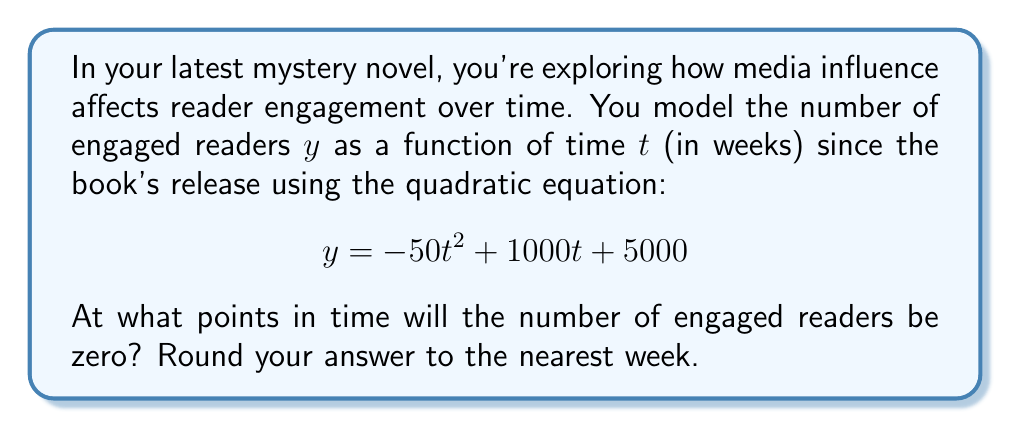Can you answer this question? To find when the number of engaged readers will be zero, we need to solve the equation:

$$ -50t^2 + 1000t + 5000 = 0 $$

This is a quadratic equation in the form $at^2 + bt + c = 0$, where:
$a = -50$, $b = 1000$, and $c = 5000$

We can solve this using the quadratic formula: $t = \frac{-b \pm \sqrt{b^2 - 4ac}}{2a}$

Step 1: Calculate the discriminant
$$ b^2 - 4ac = 1000^2 - 4(-50)(5000) = 1,000,000 + 1,000,000 = 2,000,000 $$

Step 2: Apply the quadratic formula
$$ t = \frac{-1000 \pm \sqrt{2,000,000}}{2(-50)} = \frac{-1000 \pm 1414.21}{-100} $$

Step 3: Simplify
$$ t_1 = \frac{-1000 + 1414.21}{-100} \approx -4.14 $$
$$ t_2 = \frac{-1000 - 1414.21}{-100} \approx 24.14 $$

Step 4: Interpret and round
Since time cannot be negative in this context, we discard the negative solution.
Rounding 24.14 to the nearest week gives us 24 weeks.
Answer: 24 weeks 